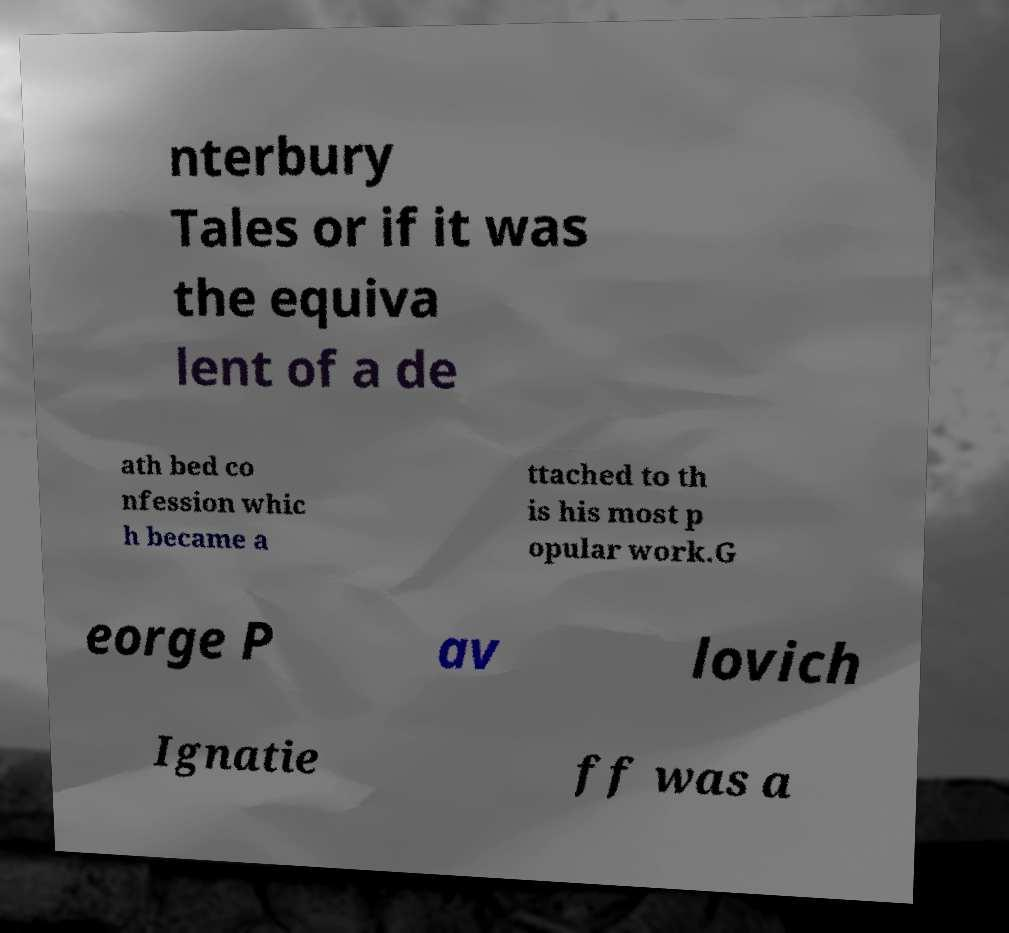Please read and relay the text visible in this image. What does it say? nterbury Tales or if it was the equiva lent of a de ath bed co nfession whic h became a ttached to th is his most p opular work.G eorge P av lovich Ignatie ff was a 